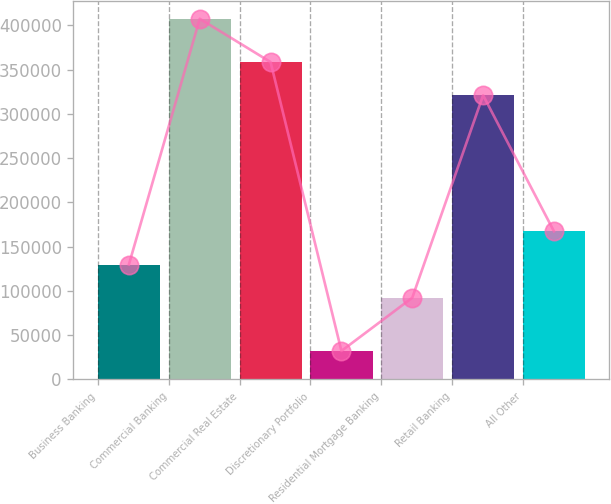<chart> <loc_0><loc_0><loc_500><loc_500><bar_chart><fcel>Business Banking<fcel>Commercial Banking<fcel>Commercial Real Estate<fcel>Discretionary Portfolio<fcel>Residential Mortgage Banking<fcel>Retail Banking<fcel>All Other<nl><fcel>129839<fcel>407393<fcel>358466<fcel>32236<fcel>92323<fcel>320950<fcel>167354<nl></chart> 